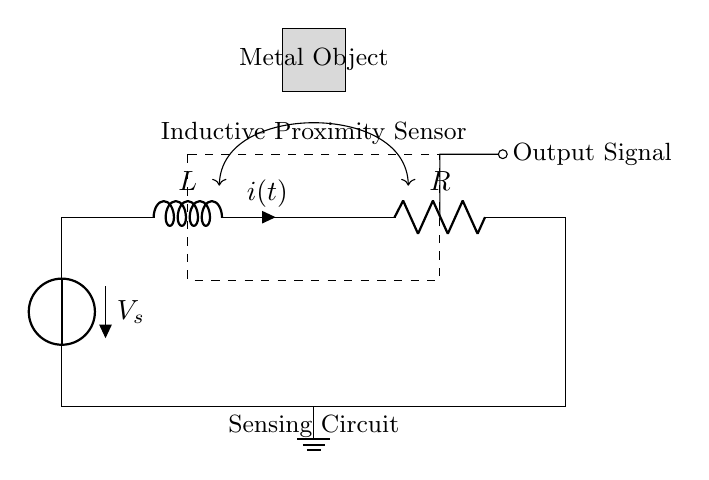What is the type of sensor used in this circuit? The circuit contains an inductive proximity sensor, which is indicated by the dashed rectangle labeled as such. This sensor is specifically designed to detect metal objects in its proximity.
Answer: inductive proximity sensor What component is represented by the dotted rectangle? The dotted rectangle represents the inductive proximity sensor, which is the main component in the circuit for detecting nearby metal objects.
Answer: inductive proximity sensor What does the inductor represent in this circuit? The inductor, labeled as "L", represents a reactive component that stores energy in its magnetic field when current passes through it. It plays a critical role in shaping the response of the circuit to changes in current flow.
Answer: reactive component What is the role of the resistor in this circuit? The resistor, labeled as "R", limits the current flowing through the circuit and helps stabilize the operation of the sensing component. It's essential for controlling the overall performance and preventing excessive current that could damage components.
Answer: limit current How is the output signal indicated in the circuit? The output signal is shown as an arrow (short) connected to the right side of the circuit, representing the detection output that triggers interactive exhibit elements.
Answer: output signal What effect does the metal object have on the sensor? The presence of the metal object alters the magnetic field around the inductive proximity sensor, which can change the current flowing through the inductor and activate the output signal.
Answer: alters magnetic field 